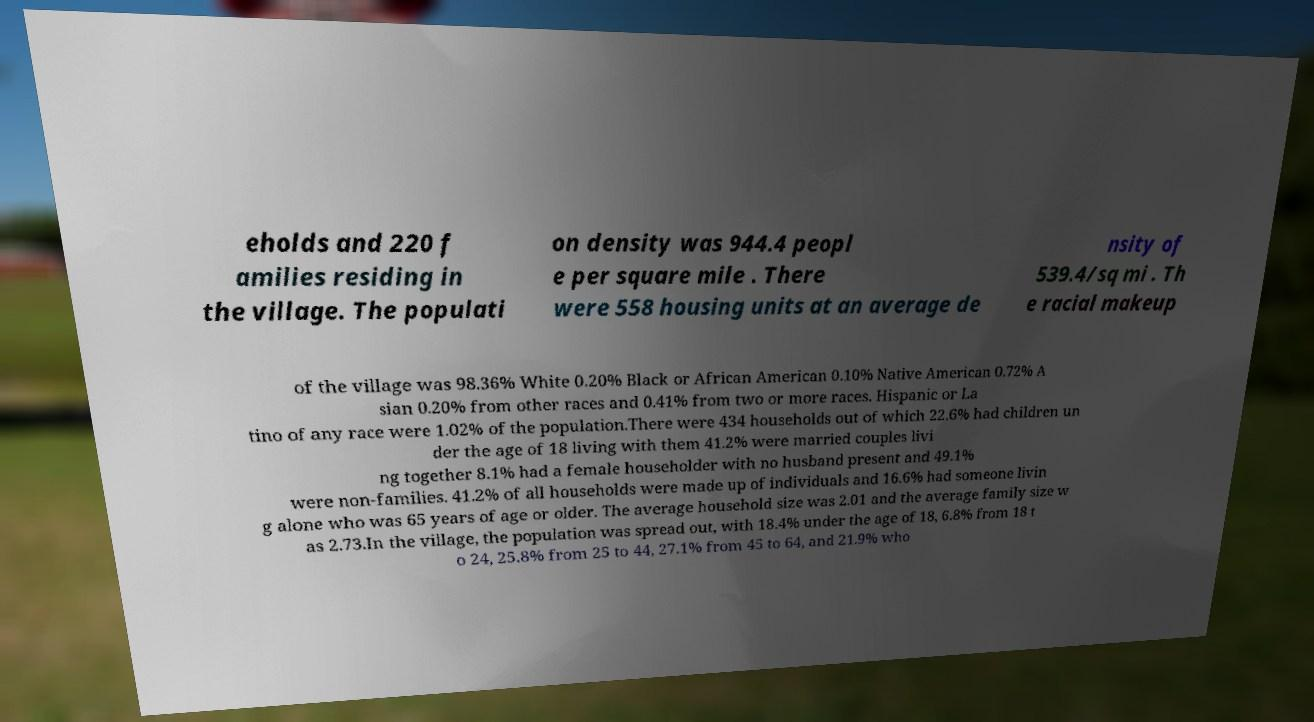Could you extract and type out the text from this image? eholds and 220 f amilies residing in the village. The populati on density was 944.4 peopl e per square mile . There were 558 housing units at an average de nsity of 539.4/sq mi . Th e racial makeup of the village was 98.36% White 0.20% Black or African American 0.10% Native American 0.72% A sian 0.20% from other races and 0.41% from two or more races. Hispanic or La tino of any race were 1.02% of the population.There were 434 households out of which 22.6% had children un der the age of 18 living with them 41.2% were married couples livi ng together 8.1% had a female householder with no husband present and 49.1% were non-families. 41.2% of all households were made up of individuals and 16.6% had someone livin g alone who was 65 years of age or older. The average household size was 2.01 and the average family size w as 2.73.In the village, the population was spread out, with 18.4% under the age of 18, 6.8% from 18 t o 24, 25.8% from 25 to 44, 27.1% from 45 to 64, and 21.9% who 